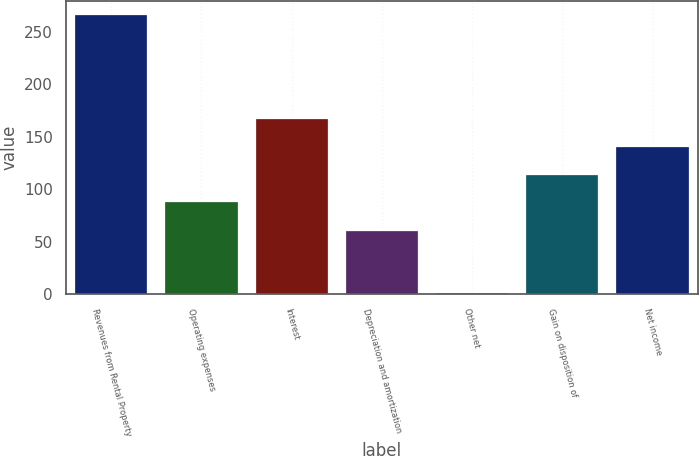Convert chart to OTSL. <chart><loc_0><loc_0><loc_500><loc_500><bar_chart><fcel>Revenues from Rental Property<fcel>Operating expenses<fcel>Interest<fcel>Depreciation and amortization<fcel>Other net<fcel>Gain on disposition of<fcel>Net income<nl><fcel>266.3<fcel>87.5<fcel>167.06<fcel>60.3<fcel>1.1<fcel>114.02<fcel>140.54<nl></chart> 